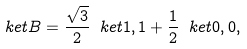Convert formula to latex. <formula><loc_0><loc_0><loc_500><loc_500>\ k e t { B } = \frac { \sqrt { 3 } } { 2 } \ k e t { 1 , 1 } + \frac { 1 } { 2 } \ k e t { 0 , 0 } ,</formula> 